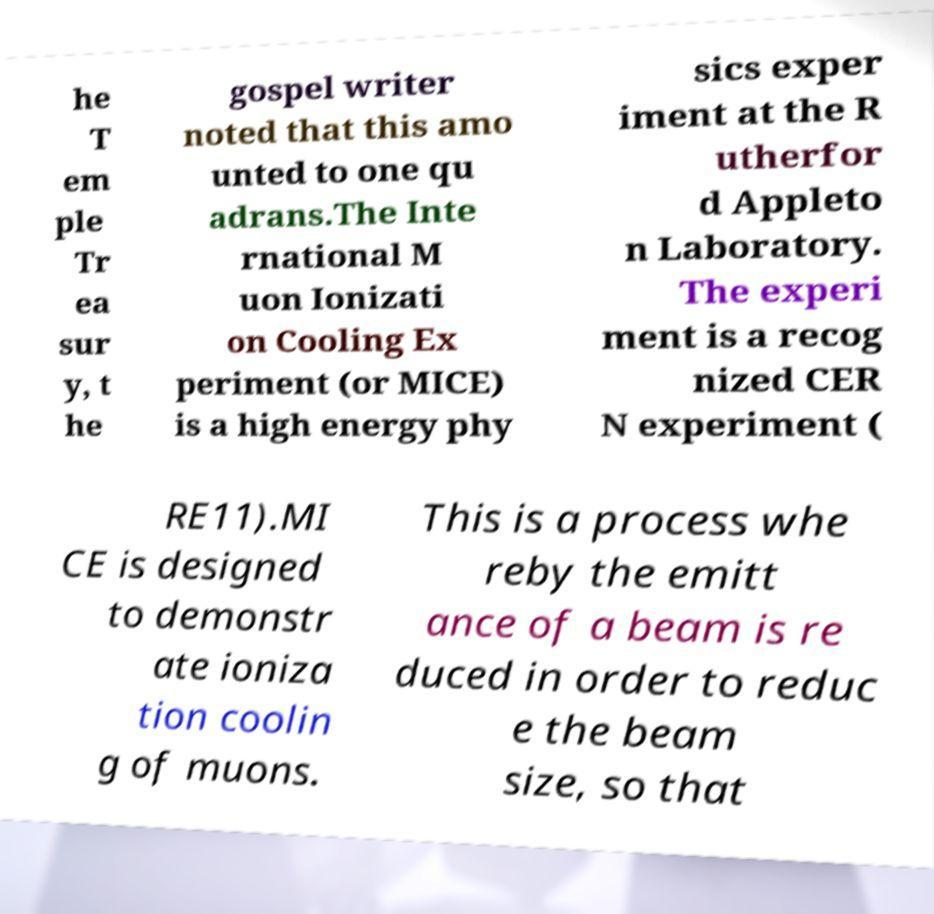Can you read and provide the text displayed in the image?This photo seems to have some interesting text. Can you extract and type it out for me? he T em ple Tr ea sur y, t he gospel writer noted that this amo unted to one qu adrans.The Inte rnational M uon Ionizati on Cooling Ex periment (or MICE) is a high energy phy sics exper iment at the R utherfor d Appleto n Laboratory. The experi ment is a recog nized CER N experiment ( RE11).MI CE is designed to demonstr ate ioniza tion coolin g of muons. This is a process whe reby the emitt ance of a beam is re duced in order to reduc e the beam size, so that 